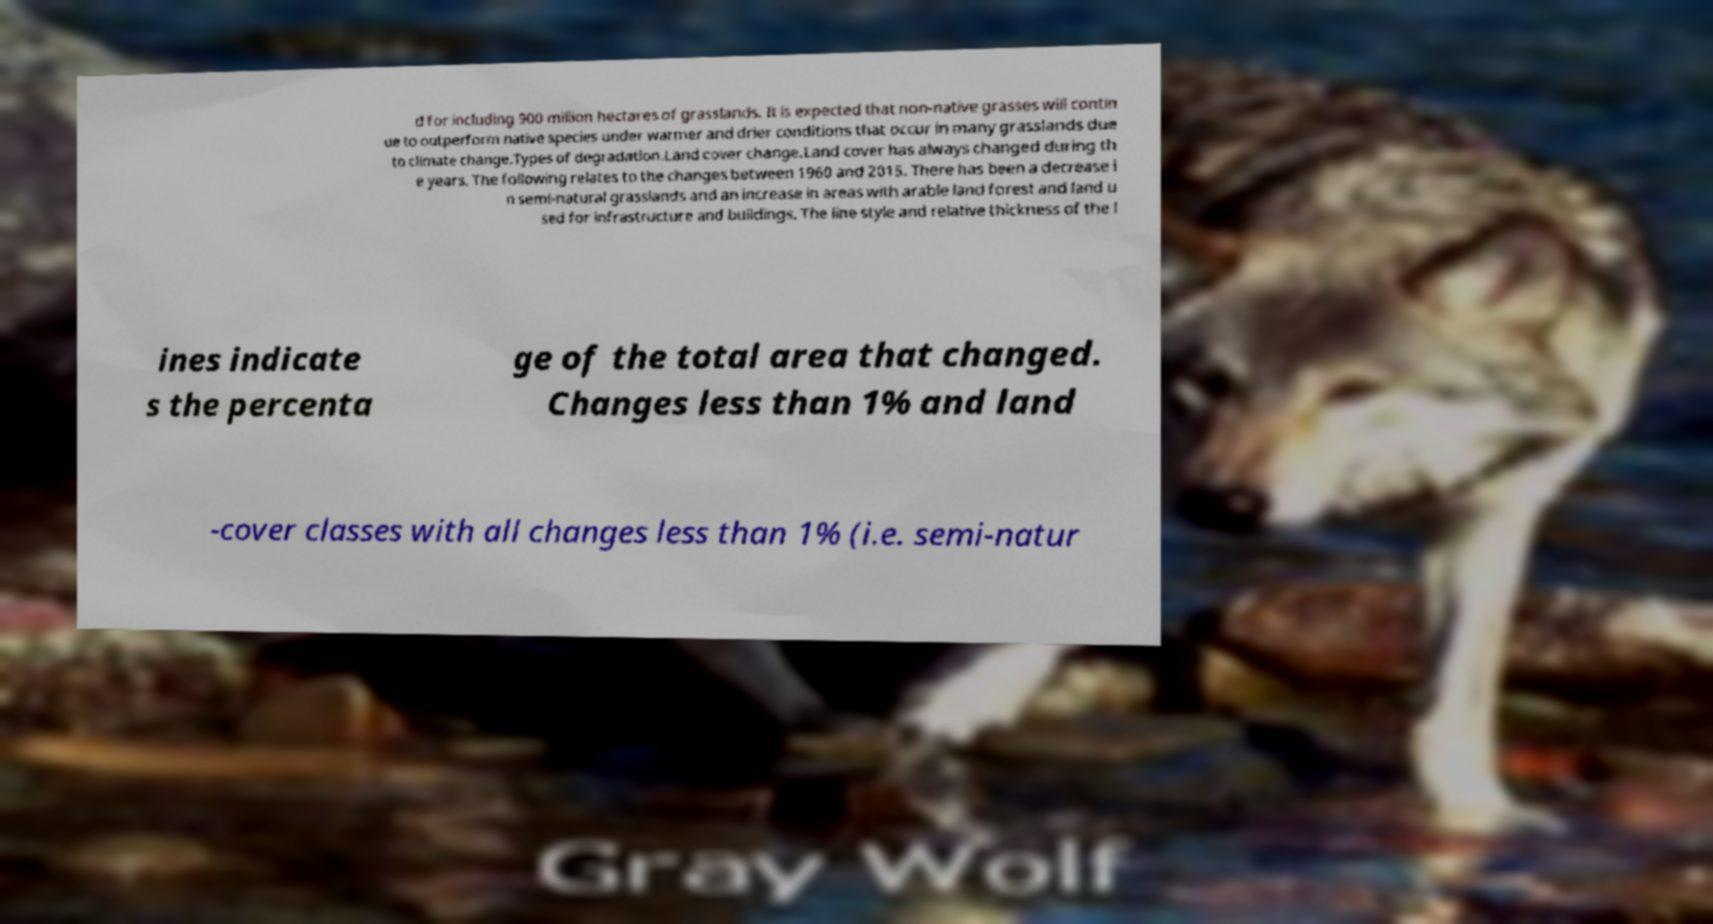There's text embedded in this image that I need extracted. Can you transcribe it verbatim? d for including 900 million hectares of grasslands. It is expected that non-native grasses will contin ue to outperform native species under warmer and drier conditions that occur in many grasslands due to climate change.Types of degradation.Land cover change.Land cover has always changed during th e years. The following relates to the changes between 1960 and 2015. There has been a decrease i n semi-natural grasslands and an increase in areas with arable land forest and land u sed for infrastructure and buildings. The line style and relative thickness of the l ines indicate s the percenta ge of the total area that changed. Changes less than 1% and land -cover classes with all changes less than 1% (i.e. semi-natur 